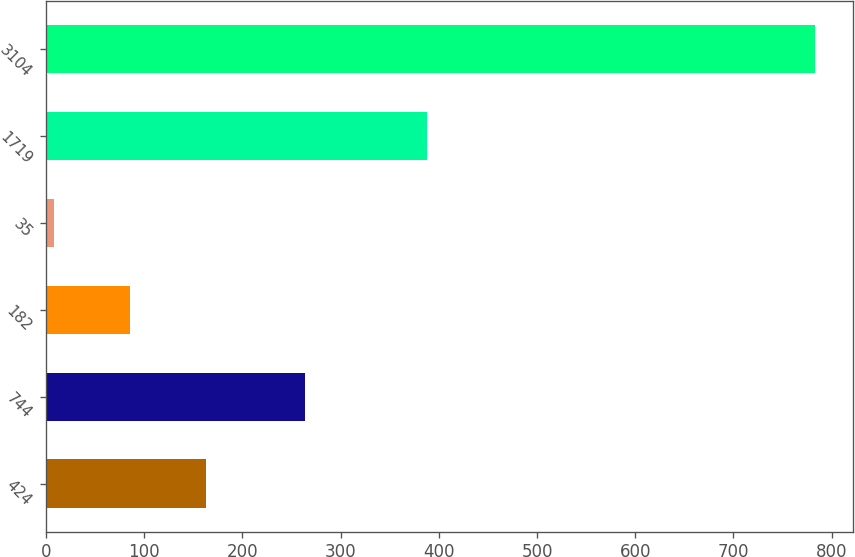Convert chart. <chart><loc_0><loc_0><loc_500><loc_500><bar_chart><fcel>424<fcel>744<fcel>182<fcel>35<fcel>1719<fcel>3104<nl><fcel>163.34<fcel>263.9<fcel>85.92<fcel>8.5<fcel>387.6<fcel>782.7<nl></chart> 